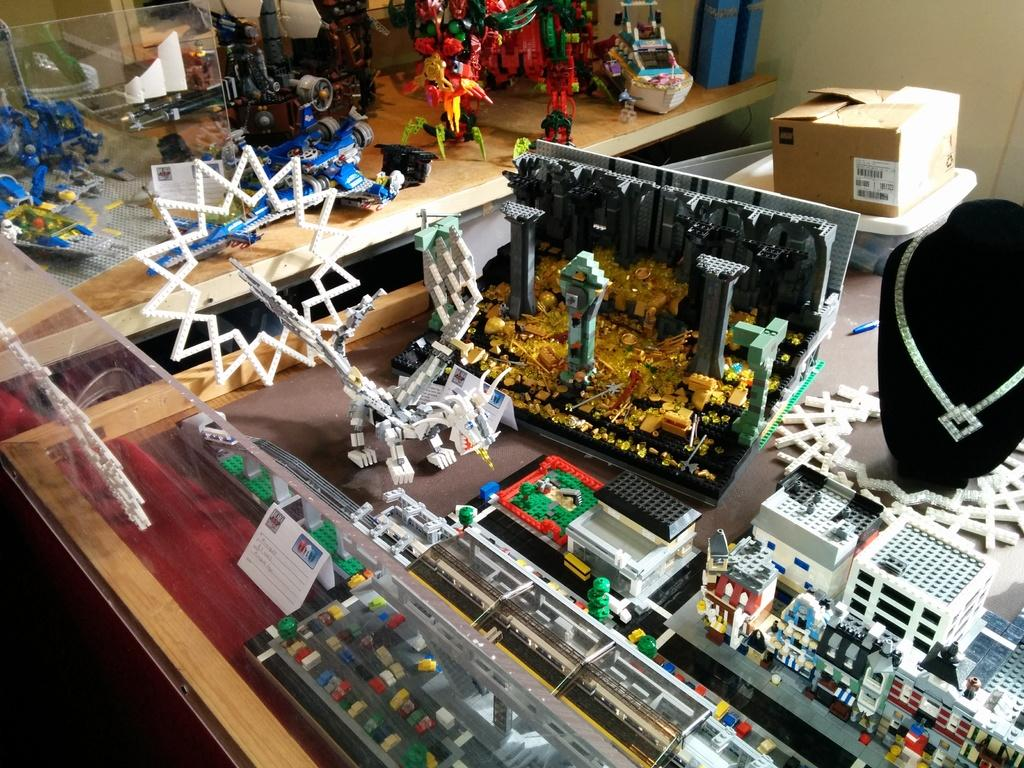What can be observed in the image regarding the variety of objects? There are different types of objects in the image. Can you describe one specific object in the image? There is an ornament in the image. What level of education does the farmer in the image have? There is no farmer present in the image, and therefore no level of education can be determined. What book is the person in the image reading? There is no person reading a book in the image. 